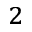<formula> <loc_0><loc_0><loc_500><loc_500>_ { 2 }</formula> 